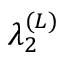<formula> <loc_0><loc_0><loc_500><loc_500>\lambda _ { 2 } ^ { ( L ) }</formula> 